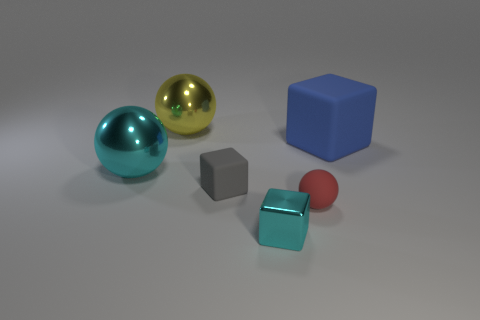Are there any other things that are the same shape as the yellow object?
Ensure brevity in your answer.  Yes. There is a small rubber thing that is the same shape as the tiny cyan metallic object; what color is it?
Offer a terse response. Gray. Does the big cyan thing have the same shape as the large metallic thing that is behind the blue rubber block?
Keep it short and to the point. Yes. What number of objects are either big metallic things that are behind the large cyan shiny ball or spheres that are left of the cyan block?
Your answer should be very brief. 2. What is the material of the large yellow thing?
Your answer should be compact. Metal. What number of other things are there of the same size as the cyan metal ball?
Ensure brevity in your answer.  2. How big is the matte object on the left side of the small cyan object?
Make the answer very short. Small. There is a cyan object in front of the thing that is left of the large sphere to the right of the large cyan shiny object; what is its material?
Your answer should be very brief. Metal. Do the small cyan thing and the large yellow shiny object have the same shape?
Your response must be concise. No. What number of metallic objects are either yellow things or cyan spheres?
Offer a terse response. 2. 